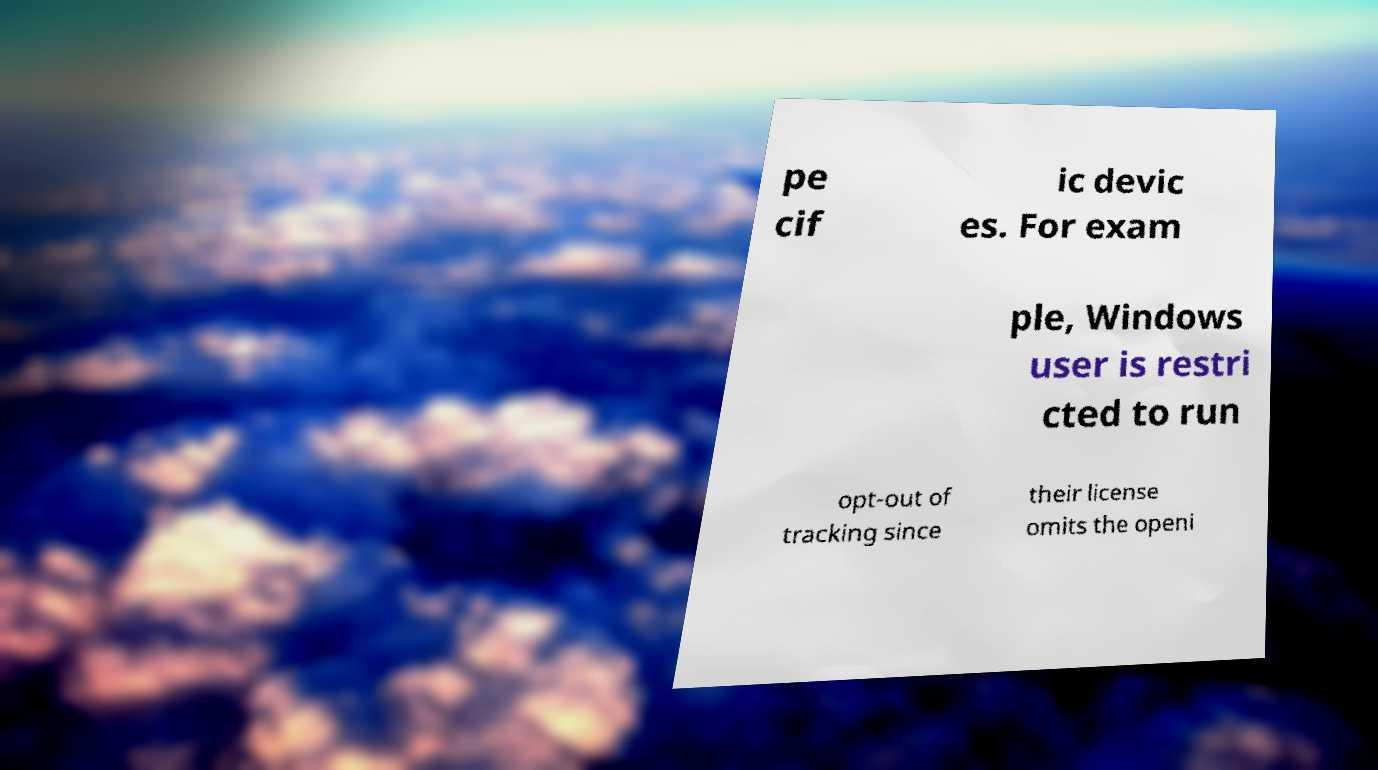Could you extract and type out the text from this image? pe cif ic devic es. For exam ple, Windows user is restri cted to run opt-out of tracking since their license omits the openi 